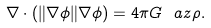<formula> <loc_0><loc_0><loc_500><loc_500>\nabla \cdot \left ( { \| \nabla \phi \| } \nabla \phi \right ) = 4 \pi G \ a z \rho .</formula> 